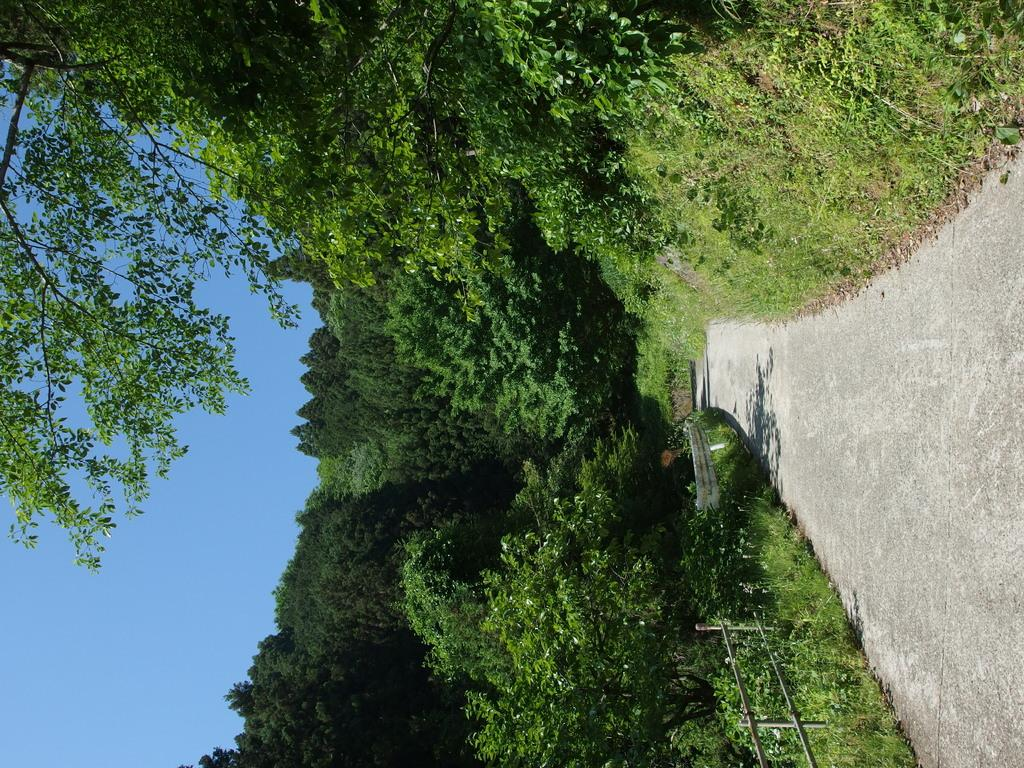What type of vegetation can be seen in the image? There are plants and trees in the image. What is the boundary between the vegetation and another area in the image? There is a fence in the image. What type of ground cover is present in the image? There is grass in the image. What can be seen in the background of the image? The sky is visible in the background of the image. What type of toys can be seen in the crib in the image? There is no crib or toys present in the image. 